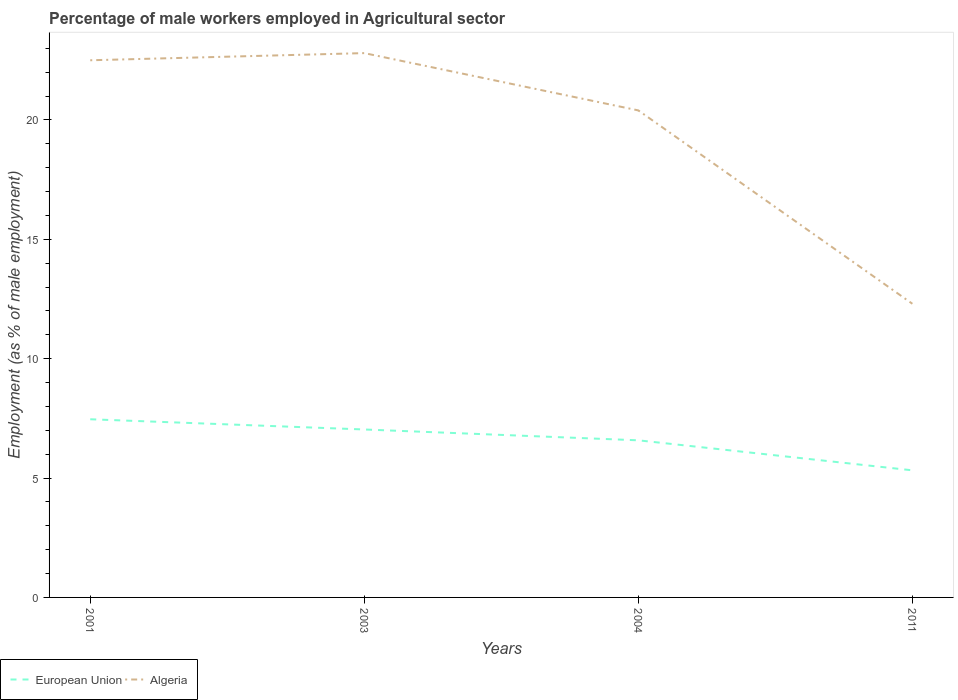How many different coloured lines are there?
Give a very brief answer. 2. Is the number of lines equal to the number of legend labels?
Ensure brevity in your answer.  Yes. Across all years, what is the maximum percentage of male workers employed in Agricultural sector in Algeria?
Your answer should be compact. 12.3. What is the total percentage of male workers employed in Agricultural sector in European Union in the graph?
Provide a succinct answer. 0.88. What is the difference between the highest and the second highest percentage of male workers employed in Agricultural sector in European Union?
Give a very brief answer. 2.14. Is the percentage of male workers employed in Agricultural sector in European Union strictly greater than the percentage of male workers employed in Agricultural sector in Algeria over the years?
Ensure brevity in your answer.  Yes. How many years are there in the graph?
Provide a succinct answer. 4. Are the values on the major ticks of Y-axis written in scientific E-notation?
Your answer should be very brief. No. Does the graph contain any zero values?
Offer a very short reply. No. How many legend labels are there?
Your answer should be very brief. 2. How are the legend labels stacked?
Offer a terse response. Horizontal. What is the title of the graph?
Ensure brevity in your answer.  Percentage of male workers employed in Agricultural sector. Does "St. Kitts and Nevis" appear as one of the legend labels in the graph?
Keep it short and to the point. No. What is the label or title of the X-axis?
Your response must be concise. Years. What is the label or title of the Y-axis?
Give a very brief answer. Employment (as % of male employment). What is the Employment (as % of male employment) in European Union in 2001?
Offer a very short reply. 7.46. What is the Employment (as % of male employment) in Algeria in 2001?
Offer a very short reply. 22.5. What is the Employment (as % of male employment) in European Union in 2003?
Your answer should be compact. 7.04. What is the Employment (as % of male employment) of Algeria in 2003?
Provide a short and direct response. 22.8. What is the Employment (as % of male employment) in European Union in 2004?
Your answer should be very brief. 6.58. What is the Employment (as % of male employment) of Algeria in 2004?
Your answer should be compact. 20.4. What is the Employment (as % of male employment) of European Union in 2011?
Offer a very short reply. 5.32. What is the Employment (as % of male employment) in Algeria in 2011?
Your response must be concise. 12.3. Across all years, what is the maximum Employment (as % of male employment) in European Union?
Provide a short and direct response. 7.46. Across all years, what is the maximum Employment (as % of male employment) of Algeria?
Make the answer very short. 22.8. Across all years, what is the minimum Employment (as % of male employment) of European Union?
Make the answer very short. 5.32. Across all years, what is the minimum Employment (as % of male employment) in Algeria?
Provide a short and direct response. 12.3. What is the total Employment (as % of male employment) of European Union in the graph?
Your answer should be very brief. 26.4. What is the difference between the Employment (as % of male employment) of European Union in 2001 and that in 2003?
Offer a very short reply. 0.43. What is the difference between the Employment (as % of male employment) of European Union in 2001 and that in 2004?
Your response must be concise. 0.88. What is the difference between the Employment (as % of male employment) of European Union in 2001 and that in 2011?
Make the answer very short. 2.14. What is the difference between the Employment (as % of male employment) in Algeria in 2001 and that in 2011?
Offer a very short reply. 10.2. What is the difference between the Employment (as % of male employment) of European Union in 2003 and that in 2004?
Offer a very short reply. 0.45. What is the difference between the Employment (as % of male employment) in Algeria in 2003 and that in 2004?
Ensure brevity in your answer.  2.4. What is the difference between the Employment (as % of male employment) in European Union in 2003 and that in 2011?
Give a very brief answer. 1.71. What is the difference between the Employment (as % of male employment) in European Union in 2004 and that in 2011?
Your response must be concise. 1.26. What is the difference between the Employment (as % of male employment) in Algeria in 2004 and that in 2011?
Your answer should be very brief. 8.1. What is the difference between the Employment (as % of male employment) in European Union in 2001 and the Employment (as % of male employment) in Algeria in 2003?
Provide a short and direct response. -15.34. What is the difference between the Employment (as % of male employment) of European Union in 2001 and the Employment (as % of male employment) of Algeria in 2004?
Provide a short and direct response. -12.94. What is the difference between the Employment (as % of male employment) in European Union in 2001 and the Employment (as % of male employment) in Algeria in 2011?
Offer a very short reply. -4.84. What is the difference between the Employment (as % of male employment) of European Union in 2003 and the Employment (as % of male employment) of Algeria in 2004?
Offer a very short reply. -13.36. What is the difference between the Employment (as % of male employment) of European Union in 2003 and the Employment (as % of male employment) of Algeria in 2011?
Make the answer very short. -5.26. What is the difference between the Employment (as % of male employment) of European Union in 2004 and the Employment (as % of male employment) of Algeria in 2011?
Keep it short and to the point. -5.72. What is the average Employment (as % of male employment) in European Union per year?
Ensure brevity in your answer.  6.6. In the year 2001, what is the difference between the Employment (as % of male employment) of European Union and Employment (as % of male employment) of Algeria?
Give a very brief answer. -15.04. In the year 2003, what is the difference between the Employment (as % of male employment) in European Union and Employment (as % of male employment) in Algeria?
Give a very brief answer. -15.76. In the year 2004, what is the difference between the Employment (as % of male employment) of European Union and Employment (as % of male employment) of Algeria?
Offer a terse response. -13.82. In the year 2011, what is the difference between the Employment (as % of male employment) of European Union and Employment (as % of male employment) of Algeria?
Make the answer very short. -6.98. What is the ratio of the Employment (as % of male employment) of European Union in 2001 to that in 2003?
Offer a very short reply. 1.06. What is the ratio of the Employment (as % of male employment) in European Union in 2001 to that in 2004?
Provide a short and direct response. 1.13. What is the ratio of the Employment (as % of male employment) in Algeria in 2001 to that in 2004?
Keep it short and to the point. 1.1. What is the ratio of the Employment (as % of male employment) of European Union in 2001 to that in 2011?
Your answer should be very brief. 1.4. What is the ratio of the Employment (as % of male employment) of Algeria in 2001 to that in 2011?
Your answer should be very brief. 1.83. What is the ratio of the Employment (as % of male employment) in European Union in 2003 to that in 2004?
Offer a very short reply. 1.07. What is the ratio of the Employment (as % of male employment) in Algeria in 2003 to that in 2004?
Your answer should be very brief. 1.12. What is the ratio of the Employment (as % of male employment) of European Union in 2003 to that in 2011?
Give a very brief answer. 1.32. What is the ratio of the Employment (as % of male employment) of Algeria in 2003 to that in 2011?
Provide a short and direct response. 1.85. What is the ratio of the Employment (as % of male employment) in European Union in 2004 to that in 2011?
Give a very brief answer. 1.24. What is the ratio of the Employment (as % of male employment) in Algeria in 2004 to that in 2011?
Give a very brief answer. 1.66. What is the difference between the highest and the second highest Employment (as % of male employment) in European Union?
Keep it short and to the point. 0.43. What is the difference between the highest and the second highest Employment (as % of male employment) of Algeria?
Ensure brevity in your answer.  0.3. What is the difference between the highest and the lowest Employment (as % of male employment) of European Union?
Offer a very short reply. 2.14. What is the difference between the highest and the lowest Employment (as % of male employment) in Algeria?
Provide a short and direct response. 10.5. 